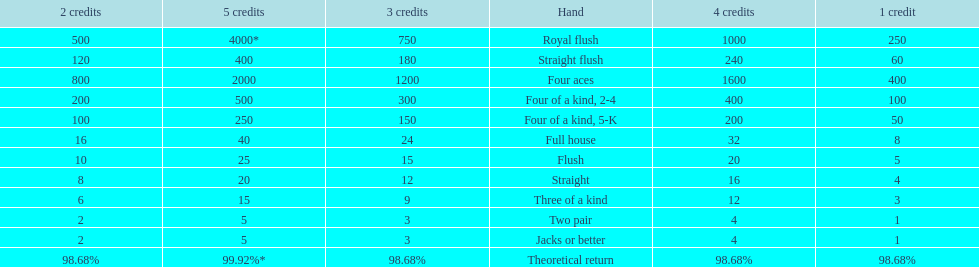The number of credits returned for a one credit bet on a royal flush are. 250. 